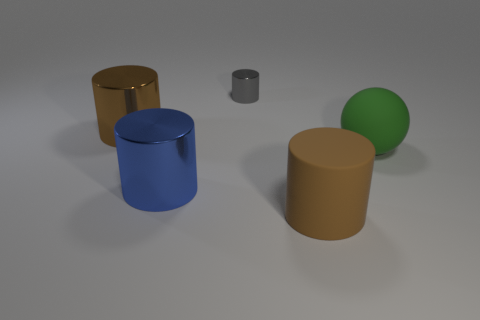How many rubber balls are to the right of the brown metallic object?
Offer a terse response. 1. Is the material of the big brown thing in front of the blue metal cylinder the same as the green sphere?
Offer a terse response. Yes. What number of tiny metal things have the same shape as the large green thing?
Provide a succinct answer. 0. What number of big objects are either matte spheres or brown things?
Make the answer very short. 3. There is a large cylinder right of the tiny metallic thing; does it have the same color as the small cylinder?
Your answer should be compact. No. Is the color of the large cylinder that is behind the green rubber sphere the same as the rubber thing behind the big blue metallic thing?
Give a very brief answer. No. Are there any green balls that have the same material as the gray cylinder?
Ensure brevity in your answer.  No. How many brown objects are either large rubber things or metal balls?
Make the answer very short. 1. Are there more blue shiny objects behind the green rubber sphere than cylinders?
Make the answer very short. No. Do the brown metal thing and the matte cylinder have the same size?
Offer a terse response. Yes. 